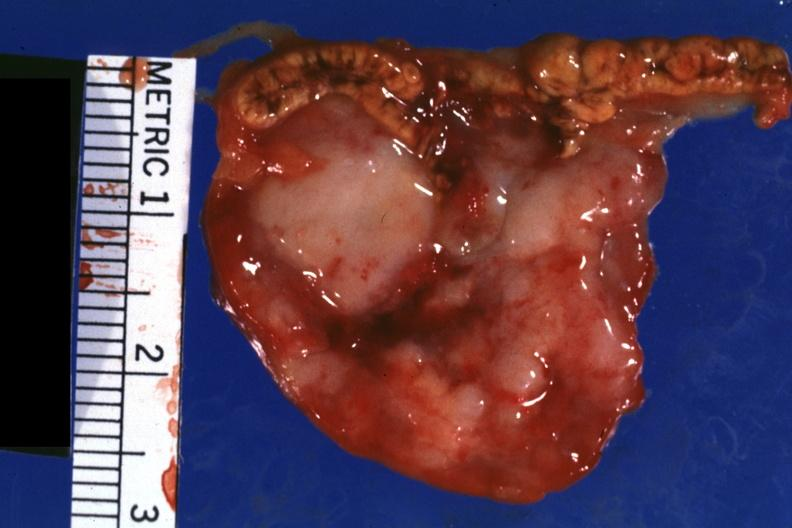what is bloody?
Answer the question using a single word or phrase. Photo 